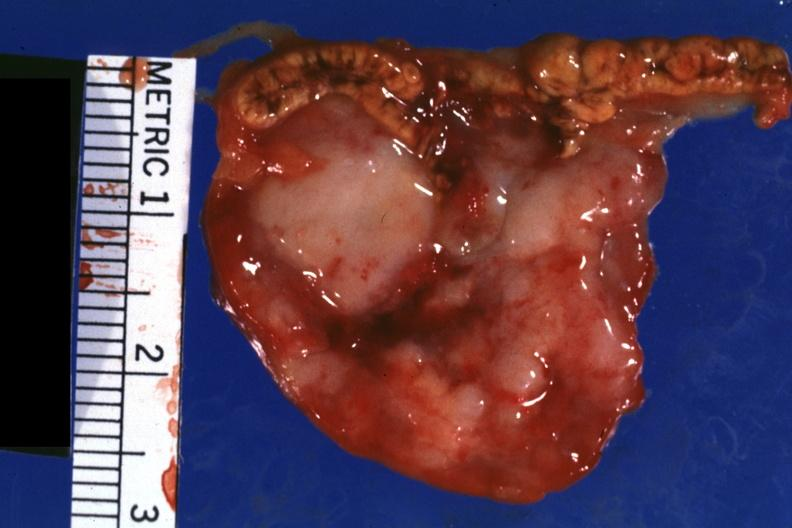what is bloody?
Answer the question using a single word or phrase. Photo 